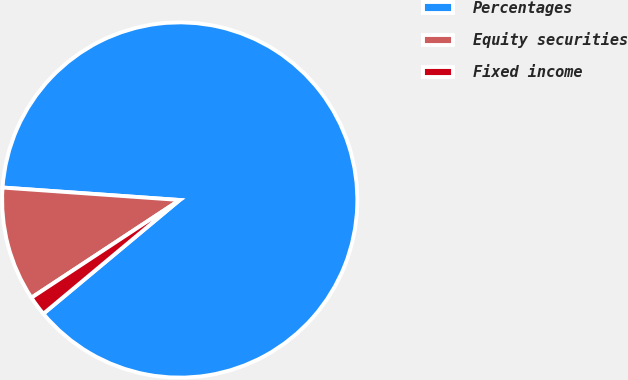Convert chart to OTSL. <chart><loc_0><loc_0><loc_500><loc_500><pie_chart><fcel>Percentages<fcel>Equity securities<fcel>Fixed income<nl><fcel>87.82%<fcel>10.39%<fcel>1.79%<nl></chart> 